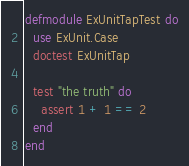Convert code to text. <code><loc_0><loc_0><loc_500><loc_500><_Elixir_>defmodule ExUnitTapTest do
  use ExUnit.Case
  doctest ExUnitTap

  test "the truth" do
    assert 1 + 1 == 2
  end
end
</code> 